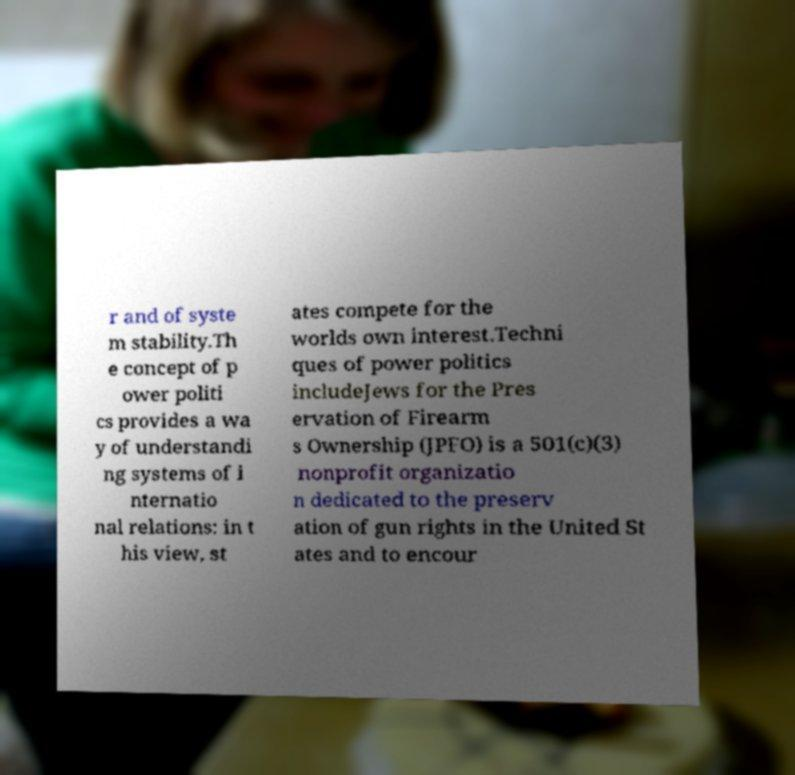Could you assist in decoding the text presented in this image and type it out clearly? r and of syste m stability.Th e concept of p ower politi cs provides a wa y of understandi ng systems of i nternatio nal relations: in t his view, st ates compete for the worlds own interest.Techni ques of power politics includeJews for the Pres ervation of Firearm s Ownership (JPFO) is a 501(c)(3) nonprofit organizatio n dedicated to the preserv ation of gun rights in the United St ates and to encour 